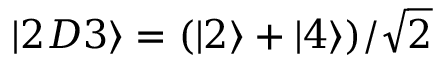<formula> <loc_0><loc_0><loc_500><loc_500>\left | 2 D 3 \right \rangle = ( \left | 2 \right \rangle + \left | 4 \right \rangle ) / \sqrt { 2 }</formula> 